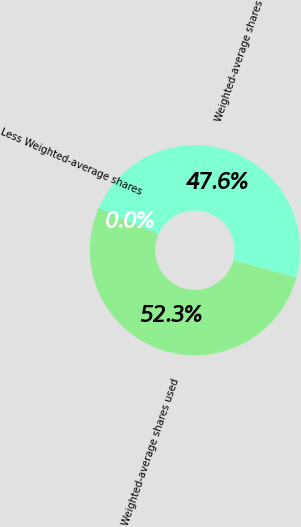Convert chart to OTSL. <chart><loc_0><loc_0><loc_500><loc_500><pie_chart><fcel>Weighted-average shares<fcel>Less Weighted-average shares<fcel>Weighted-average shares used<nl><fcel>47.63%<fcel>0.03%<fcel>52.33%<nl></chart> 